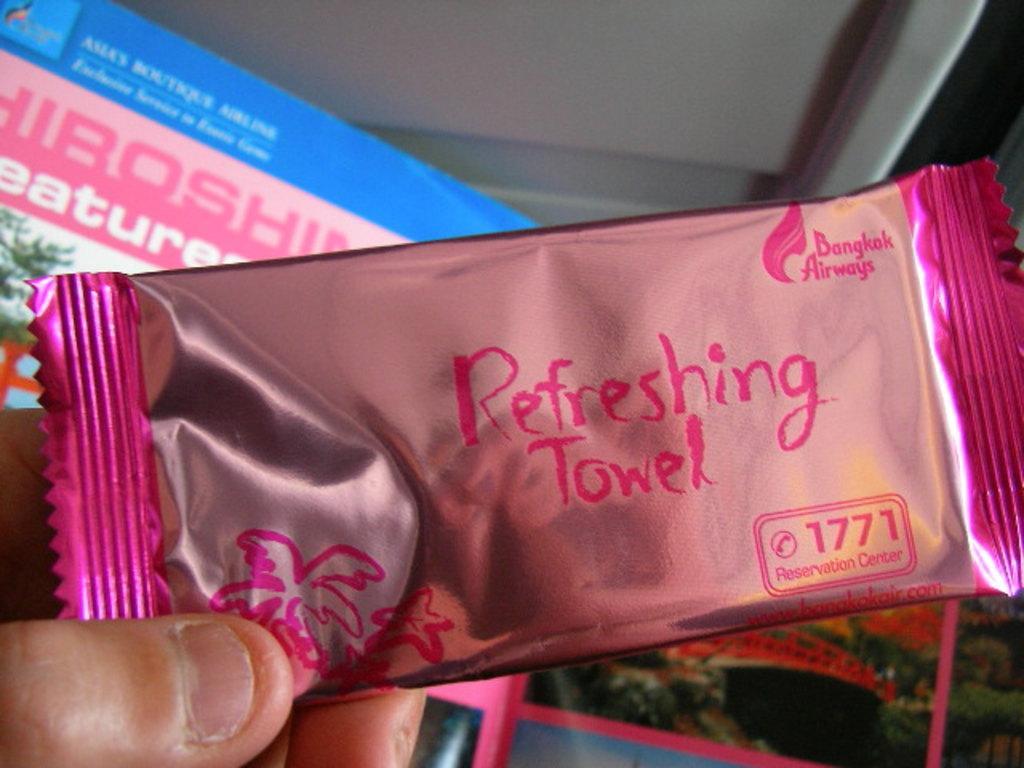In one or two sentences, can you explain what this image depicts? In this image in the front there is a hand of the person holding a packet with some text written on it which is pink in colour. In the background there is a banner with some text written on it and there are plants 